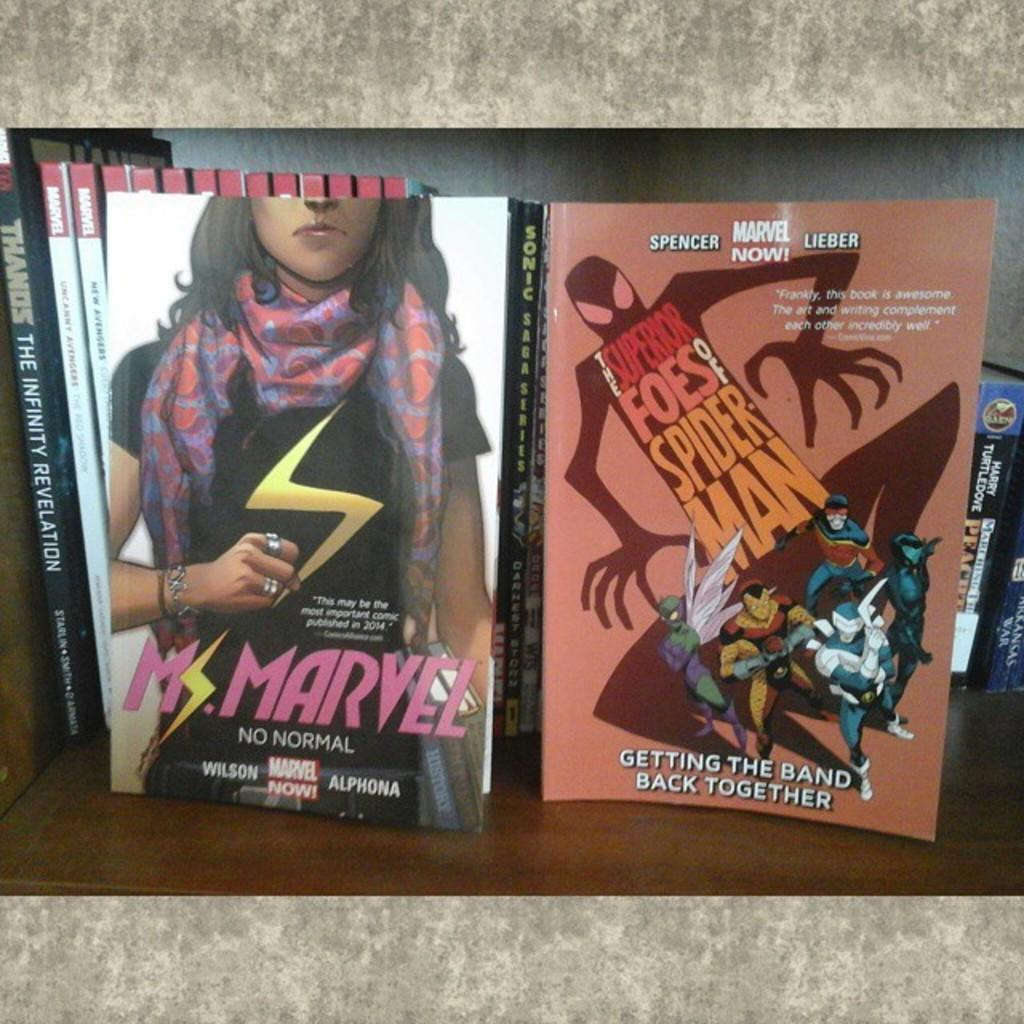Provide a one-sentence caption for the provided image. An advertisement for a Marvel movie next to another one. 